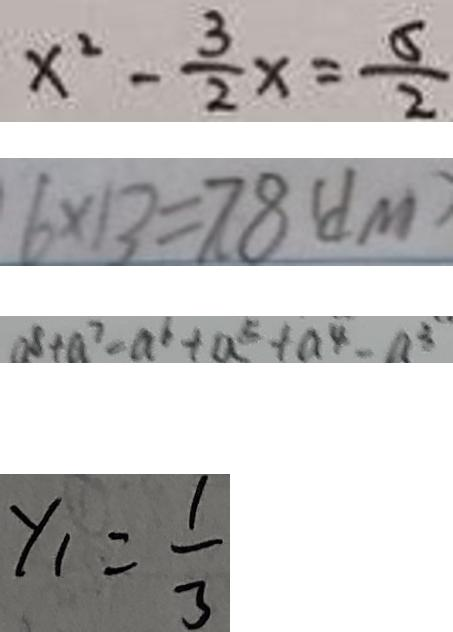Convert formula to latex. <formula><loc_0><loc_0><loc_500><loc_500>x ^ { 2 } - \frac { 3 } { 2 } x = \frac { 5 } { 2 } 
 6 \times 1 3 = 7 8 ( d m ) 
 a ^ { 8 } + a ^ { 7 } - a ^ { 6 } + a ^ { 5 } + a ^ { 4 } - a ^ { 3 } 
 y _ { 1 } = \frac { 1 } { 3 }</formula> 